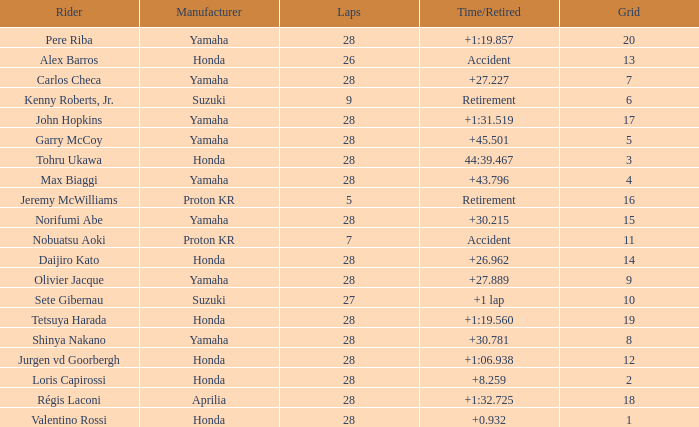Who manufactured grid 11? Proton KR. 